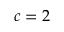<formula> <loc_0><loc_0><loc_500><loc_500>c = 2</formula> 